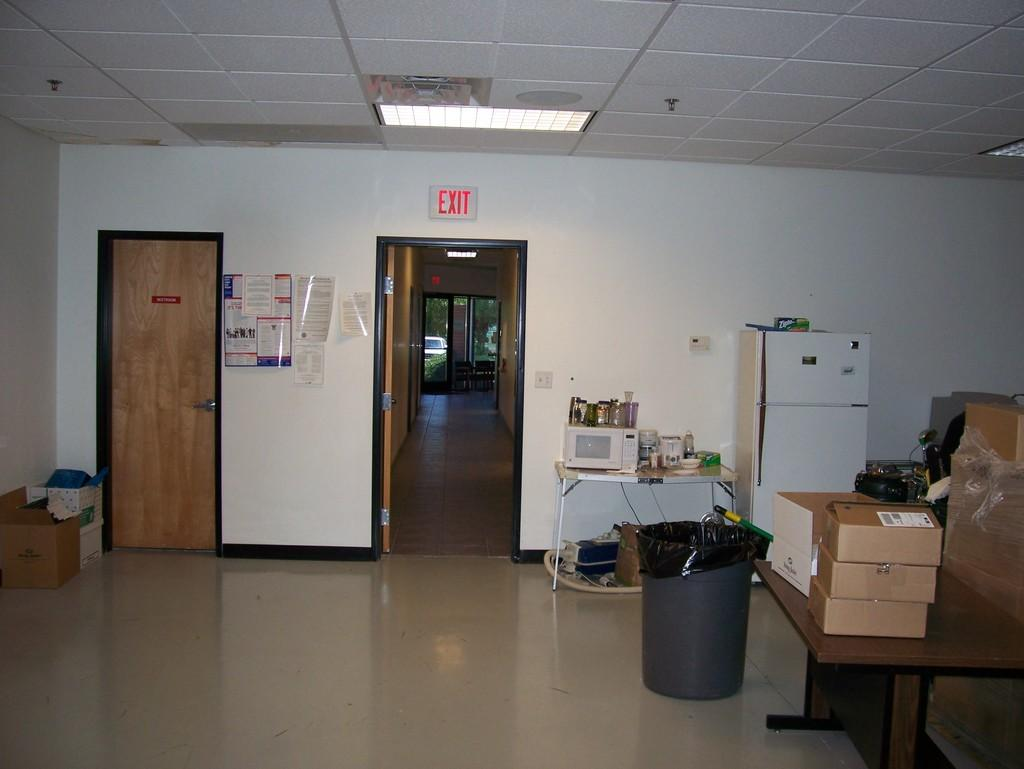What is one of the main objects in the image? There is a door in the image. What is located on the ground in the image? There is a dustbin and a fridge on the ground. What is placed on the table in the image? There are cardboard boxes and a woman on the table. How many nails can be seen in the image? There are no nails present in the image. What type of wish can be granted by the woman in the image? There is no indication in the image that the woman can grant wishes, and therefore no such activity can be observed. 